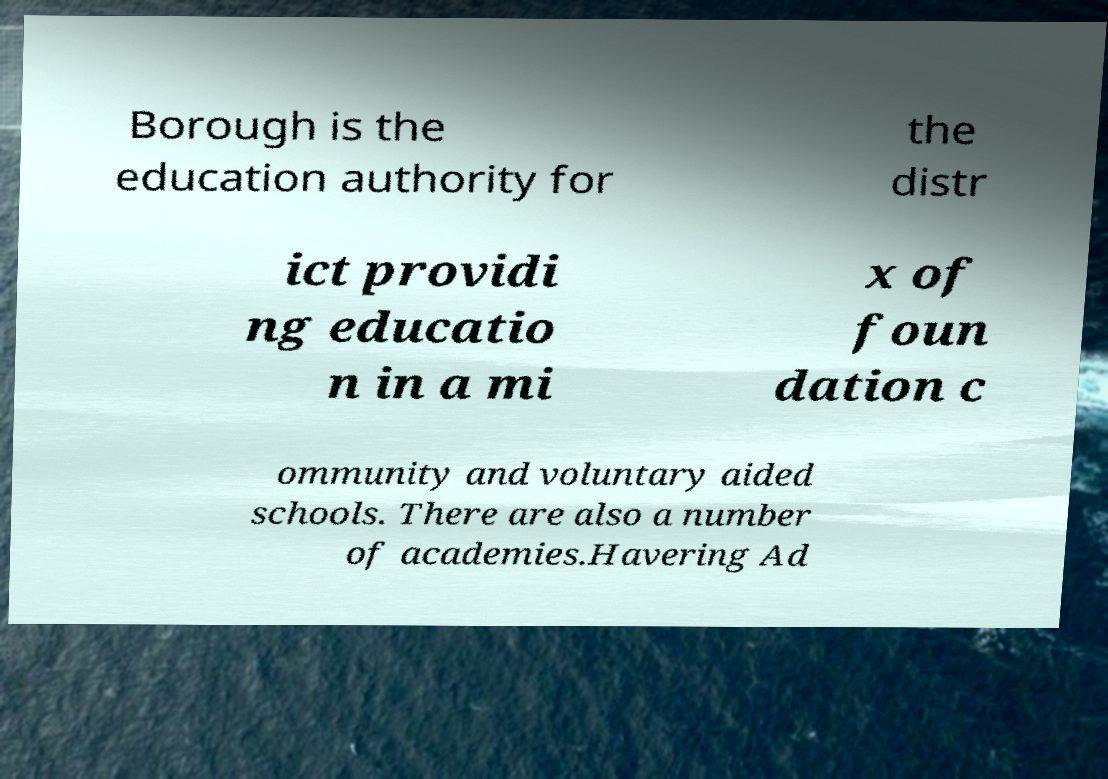Could you extract and type out the text from this image? Borough is the education authority for the distr ict providi ng educatio n in a mi x of foun dation c ommunity and voluntary aided schools. There are also a number of academies.Havering Ad 